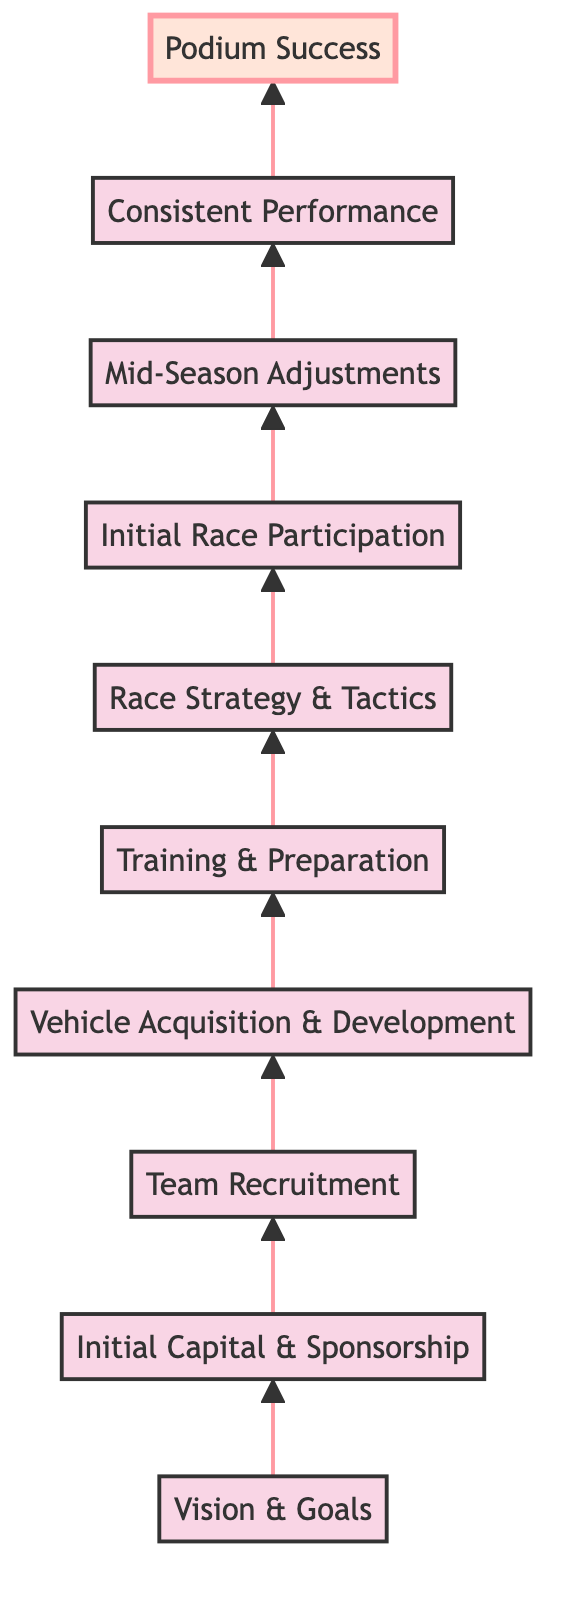What is the final outcome represented in this diagram? The diagram culminates at the topmost node labeled "Podium Success," which signifies achieving podium finishes and championships.
Answer: Podium Success How many total nodes are there in the diagram? There are 10 nodes present in the diagram, each representing a distinct stage in building a racing team.
Answer: 10 What is the second step after "Initial Capital & Sponsorship"? The diagram indicates that after securing initial capital and sponsorship, the next step is "Team Recruitment."
Answer: Team Recruitment Which node is directly above "Initial Race Participation"? The node directly above "Initial Race Participation" is "Race Strategy & Tactics," indicating the importance of strategy before participating in races.
Answer: Race Strategy & Tactics What is the immediate action following "Consistent Performance"? According to the flowchart, the immediate action after "Consistent Performance" is the achievement of "Podium Success."
Answer: Podium Success How many adjustments are indicated in the flow from "Initial Race Participation" to "Consistent Performance"? The transition from "Initial Race Participation" to "Consistent Performance" involves two key steps: "Mid-Season Adjustments" as a necessary intervention and then achieving consistent results.
Answer: 2 Which objectives are established at the base of the diagram? At the base, the initial objectives are encapsulated in the node "Vision & Goals," forming the foundation for the racing team's journey.
Answer: Vision & Goals What do the diagrams illustrate about the progression of the team's journey? The directional flow from bottom to top illustrates a systematic and logical progression through various stages, culminating in success.
Answer: Systematic progression What is illustrated as a necessary preparation step before racing? Before racing, "Training & Preparation" is identified as a necessary phase, highlighting its essential role in the team's readiness.
Answer: Training & Preparation 